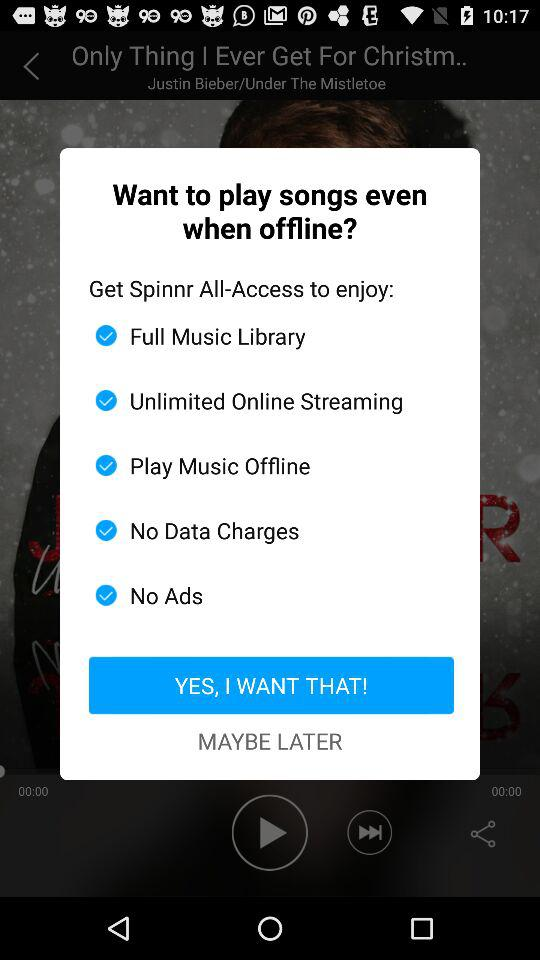How many benefits does the user get for subscribing to Spinnr All-Access?
Answer the question using a single word or phrase. 5 